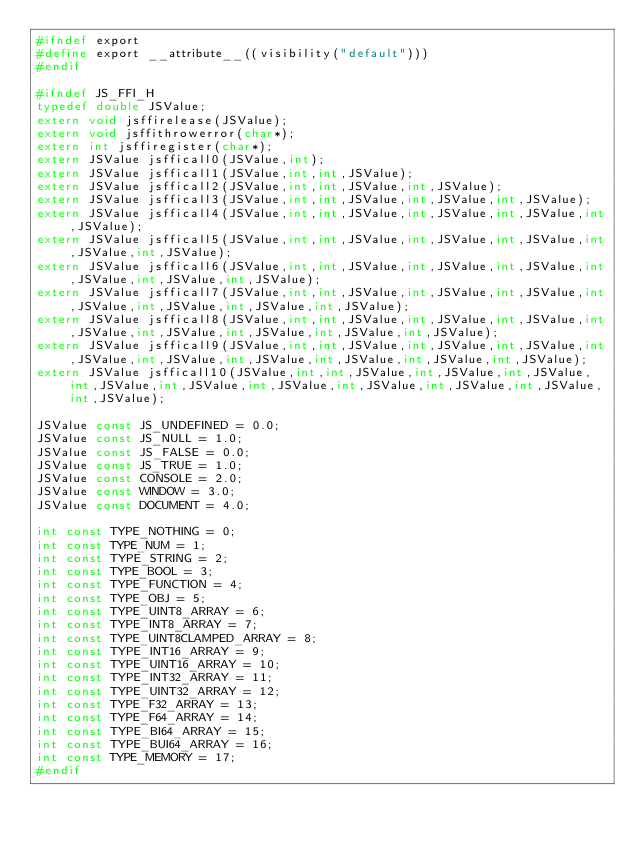<code> <loc_0><loc_0><loc_500><loc_500><_C_>#ifndef export
#define export __attribute__((visibility("default")))
#endif

#ifndef JS_FFI_H
typedef double JSValue;
extern void jsffirelease(JSValue);
extern void jsffithrowerror(char*);
extern int jsffiregister(char*);
extern JSValue jsfficall0(JSValue,int);
extern JSValue jsfficall1(JSValue,int,int,JSValue);
extern JSValue jsfficall2(JSValue,int,int,JSValue,int,JSValue);
extern JSValue jsfficall3(JSValue,int,int,JSValue,int,JSValue,int,JSValue);
extern JSValue jsfficall4(JSValue,int,int,JSValue,int,JSValue,int,JSValue,int,JSValue);
extern JSValue jsfficall5(JSValue,int,int,JSValue,int,JSValue,int,JSValue,int,JSValue,int,JSValue);
extern JSValue jsfficall6(JSValue,int,int,JSValue,int,JSValue,int,JSValue,int,JSValue,int,JSValue,int,JSValue);
extern JSValue jsfficall7(JSValue,int,int,JSValue,int,JSValue,int,JSValue,int,JSValue,int,JSValue,int,JSValue,int,JSValue);
extern JSValue jsfficall8(JSValue,int,int,JSValue,int,JSValue,int,JSValue,int,JSValue,int,JSValue,int,JSValue,int,JSValue,int,JSValue);
extern JSValue jsfficall9(JSValue,int,int,JSValue,int,JSValue,int,JSValue,int,JSValue,int,JSValue,int,JSValue,int,JSValue,int,JSValue,int,JSValue);
extern JSValue jsfficall10(JSValue,int,int,JSValue,int,JSValue,int,JSValue,int,JSValue,int,JSValue,int,JSValue,int,JSValue,int,JSValue,int,JSValue,int,JSValue);

JSValue const JS_UNDEFINED = 0.0;
JSValue const JS_NULL = 1.0;
JSValue const JS_FALSE = 0.0;
JSValue const JS_TRUE = 1.0;
JSValue const CONSOLE = 2.0;
JSValue const WINDOW = 3.0;
JSValue const DOCUMENT = 4.0;

int const TYPE_NOTHING = 0;
int const TYPE_NUM = 1;
int const TYPE_STRING = 2;
int const TYPE_BOOL = 3;
int const TYPE_FUNCTION = 4;
int const TYPE_OBJ = 5;
int const TYPE_UINT8_ARRAY = 6;
int const TYPE_INT8_ARRAY = 7;
int const TYPE_UINT8CLAMPED_ARRAY = 8;
int const TYPE_INT16_ARRAY = 9;
int const TYPE_UINT16_ARRAY = 10;
int const TYPE_INT32_ARRAY = 11;
int const TYPE_UINT32_ARRAY = 12;
int const TYPE_F32_ARRAY = 13;
int const TYPE_F64_ARRAY = 14;
int const TYPE_BI64_ARRAY = 15;
int const TYPE_BUI64_ARRAY = 16;
int const TYPE_MEMORY = 17;
#endif</code> 